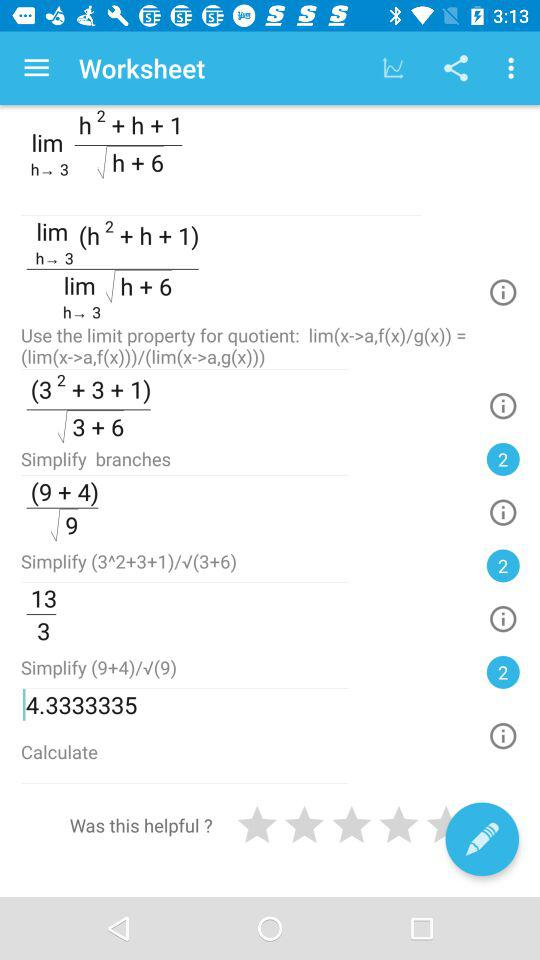What is the value of h+6 when h is 3?
Answer the question using a single word or phrase. 9 